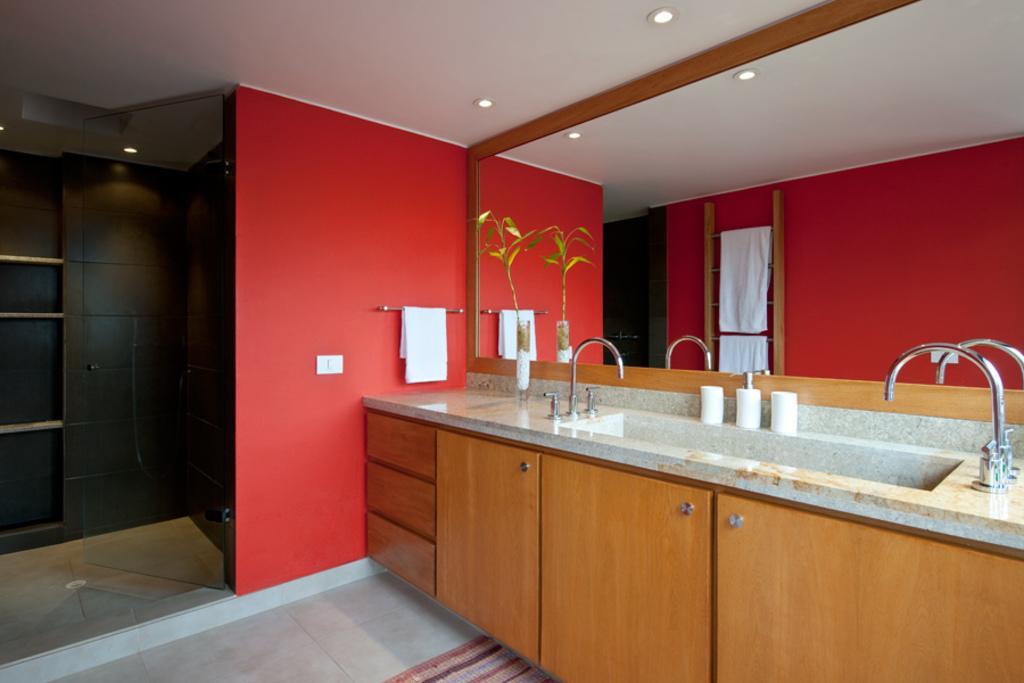Describe this image in one or two sentences. In this image, we can see sink with taps, tissue rolls, cupboards, racks, wall, mirror, house plant and rod with towel. At the bottom of the image, we can see the floor and floor mat. At the top of the image, we can see the ceiling with lights. On this mirror, we can see reflections. 